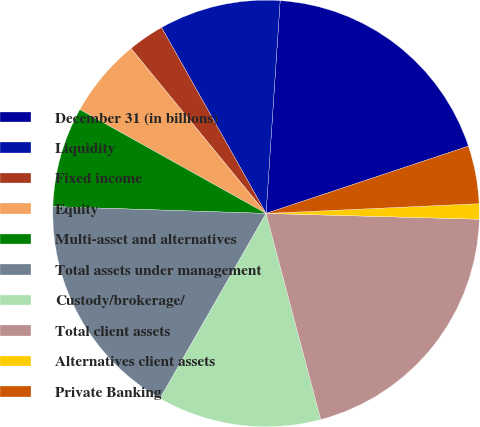Convert chart to OTSL. <chart><loc_0><loc_0><loc_500><loc_500><pie_chart><fcel>December 31 (in billions)<fcel>Liquidity<fcel>Fixed income<fcel>Equity<fcel>Multi-asset and alternatives<fcel>Total assets under management<fcel>Custody/brokerage/<fcel>Total client assets<fcel>Alternatives client assets<fcel>Private Banking<nl><fcel>18.84%<fcel>9.2%<fcel>2.77%<fcel>5.98%<fcel>7.59%<fcel>17.23%<fcel>12.41%<fcel>20.44%<fcel>1.16%<fcel>4.38%<nl></chart> 